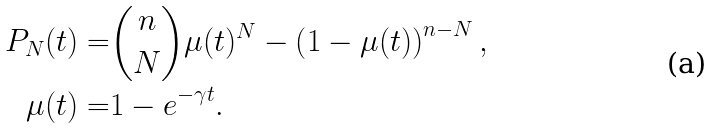<formula> <loc_0><loc_0><loc_500><loc_500>P _ { N } ( t ) = & { { n } \choose { N } } \mu ( t ) ^ { N } - \left ( 1 - \mu ( t ) \right ) ^ { n - N } , \\ \mu ( t ) = & 1 - e ^ { - \gamma t } .</formula> 